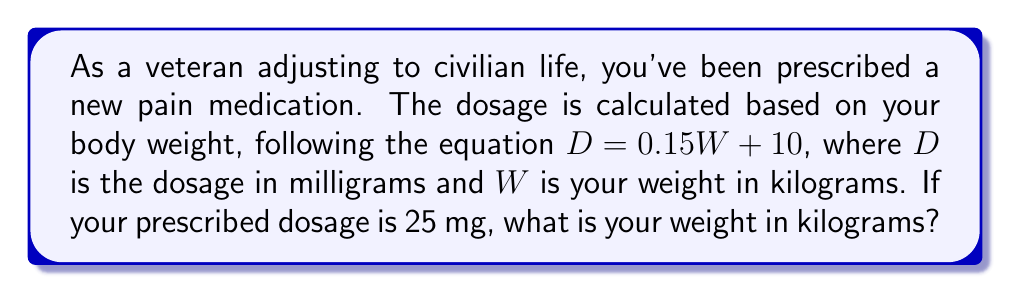Solve this math problem. Let's solve this problem step by step:

1) We're given the equation: $D = 0.15W + 10$
   Where $D$ is the dosage in mg, and $W$ is the weight in kg.

2) We know that the prescribed dosage (D) is 25 mg. Let's substitute this:
   
   $25 = 0.15W + 10$

3) To solve for W, we first subtract 10 from both sides:
   
   $25 - 10 = 0.15W + 10 - 10$
   $15 = 0.15W$

4) Now, we divide both sides by 0.15:
   
   $\frac{15}{0.15} = \frac{0.15W}{0.15}$
   $100 = W$

5) Therefore, your weight is 100 kg.

This problem demonstrates how linear equations can be used in medical contexts to determine appropriate dosages based on a patient's weight.
Answer: $100$ kg 